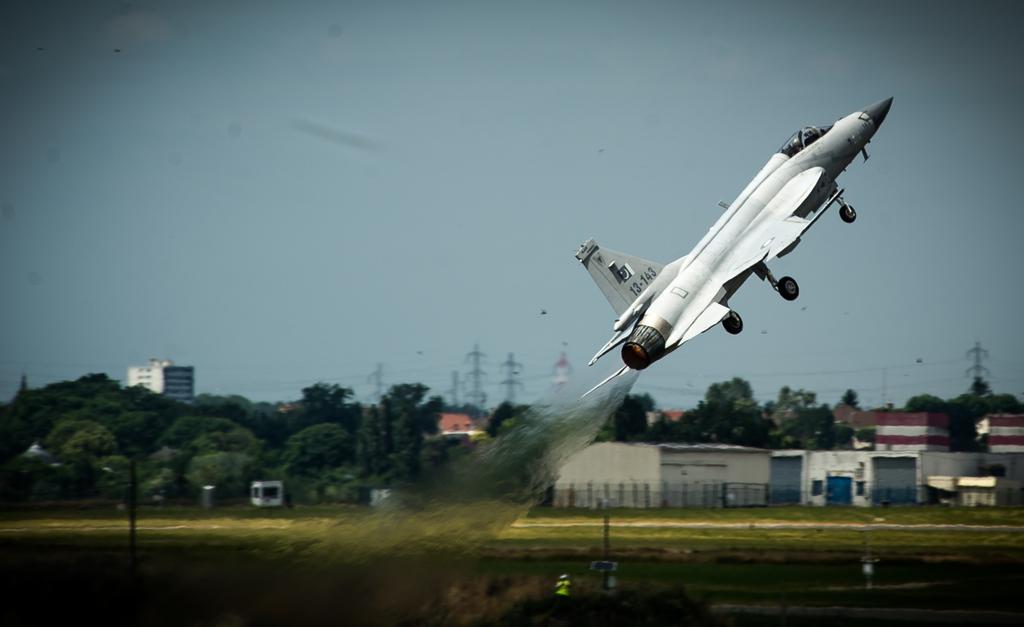What is the tail number of the jet?
Your answer should be compact. 13-143. 